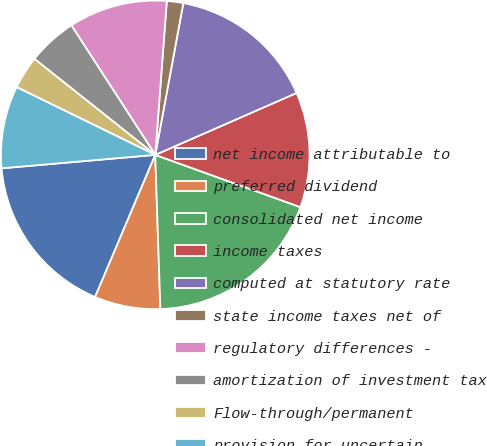Convert chart to OTSL. <chart><loc_0><loc_0><loc_500><loc_500><pie_chart><fcel>net income attributable to<fcel>preferred dividend<fcel>consolidated net income<fcel>income taxes<fcel>computed at statutory rate<fcel>state income taxes net of<fcel>regulatory differences -<fcel>amortization of investment tax<fcel>Flow-through/permanent<fcel>provision for uncertain<nl><fcel>17.24%<fcel>6.9%<fcel>18.97%<fcel>12.07%<fcel>15.52%<fcel>1.72%<fcel>10.34%<fcel>5.17%<fcel>3.45%<fcel>8.62%<nl></chart> 